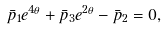<formula> <loc_0><loc_0><loc_500><loc_500>\bar { p } _ { 1 } e ^ { 4 \theta } + \bar { p } _ { 3 } e ^ { 2 \theta } - \bar { p } _ { 2 } = 0 ,</formula> 